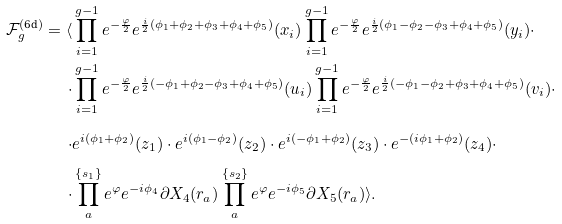Convert formula to latex. <formula><loc_0><loc_0><loc_500><loc_500>\mathcal { F } _ { g } ^ { ( \text {6d} ) } = \langle & \prod _ { i = 1 } ^ { g - 1 } e ^ { - \frac { \varphi } { 2 } } e ^ { \frac { i } { 2 } ( \phi _ { 1 } + \phi _ { 2 } + \phi _ { 3 } + \phi _ { 4 } + \phi _ { 5 } ) } ( x _ { i } ) \prod _ { i = 1 } ^ { g - 1 } e ^ { - \frac { \varphi } { 2 } } e ^ { \frac { i } { 2 } ( \phi _ { 1 } - \phi _ { 2 } - \phi _ { 3 } + \phi _ { 4 } + \phi _ { 5 } ) } ( y _ { i } ) \cdot \\ \cdot & \prod _ { i = 1 } ^ { g - 1 } e ^ { - \frac { \varphi } { 2 } } e ^ { \frac { i } { 2 } ( - \phi _ { 1 } + \phi _ { 2 } - \phi _ { 3 } + \phi _ { 4 } + \phi _ { 5 } ) } ( u _ { i } ) \prod _ { i = 1 } ^ { g - 1 } e ^ { - \frac { \varphi } { 2 } } e ^ { \frac { i } { 2 } ( - \phi _ { 1 } - \phi _ { 2 } + \phi _ { 3 } + \phi _ { 4 } + \phi _ { 5 } ) } ( v _ { i } ) \cdot \\ \cdot & e ^ { i ( \phi _ { 1 } + \phi _ { 2 } ) } ( z _ { 1 } ) \cdot e ^ { i ( \phi _ { 1 } - \phi _ { 2 } ) } ( z _ { 2 } ) \cdot e ^ { i ( - \phi _ { 1 } + \phi _ { 2 } ) } ( z _ { 3 } ) \cdot e ^ { - ( i \phi _ { 1 } + \phi _ { 2 } ) } ( z _ { 4 } ) \cdot \\ \cdot & \prod _ { a } ^ { \{ s _ { 1 } \} } e ^ { \varphi } e ^ { - i \phi _ { 4 } } \partial X _ { 4 } ( r _ { a } ) \prod _ { a } ^ { \{ s _ { 2 } \} } e ^ { \varphi } e ^ { - i \phi _ { 5 } } \partial X _ { 5 } ( r _ { a } ) \rangle .</formula> 